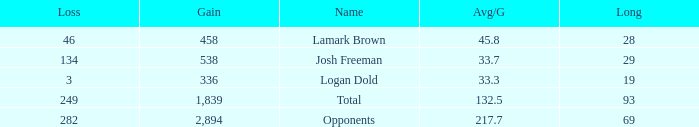Which Avg/G has a Long of 93, and a Loss smaller than 249? None. 